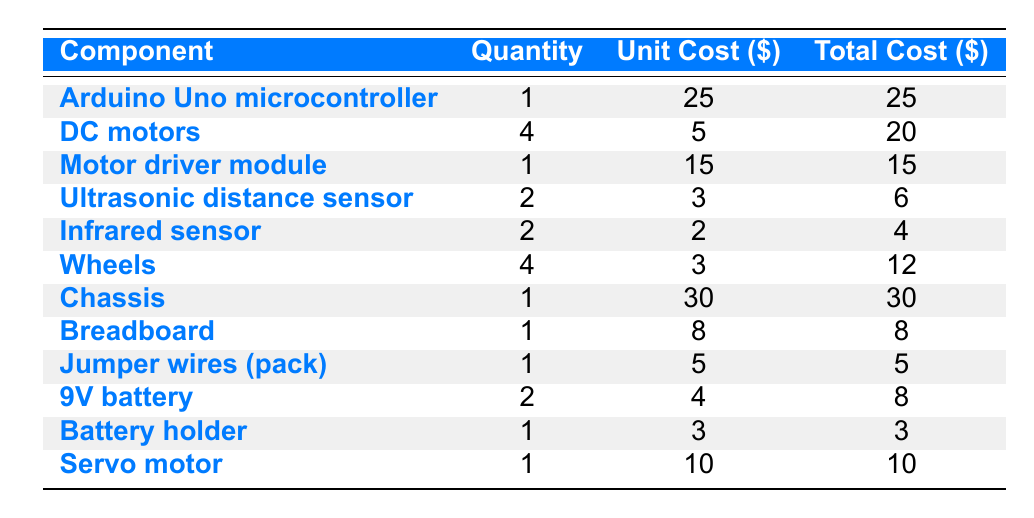What is the total cost for all components? To find the total cost, I need to sum the 'Total Cost ($)' for each component. Adding them up: 25 + 20 + 15 + 6 + 4 + 12 + 30 + 8 + 5 + 8 + 3 + 10 = 142.
Answer: 142 How many DC motors are needed to build the robot? The table explicitly states that 4 DC motors are required to build the robot.
Answer: 4 What is the unit cost of the chassis? The unit cost is provided directly in the table for the chassis, which is listed as 30 dollars.
Answer: 30 Is the total cost of the Arduino Uno microcontroller higher than the total cost of the servo motor? The total cost of the Arduino Uno microcontroller is 25 dollars and for the servo motor, it is 10 dollars. Since 25 is greater than 10, the statement is true.
Answer: Yes What is the average unit cost of the sensors (ultrasonic and infrared)? To find the average unit cost of the sensors, first identify their unit costs: ultrasonic sensor is 3 dollars (2 units) and infrared sensor is 2 dollars (2 units). The total combined unit cost is (3 + 2) = 5. There are a total of 2 types of sensors, so the average is 5/2 = 2.5.
Answer: 2.5 Which component has the highest total cost and what is the amount? By reviewing the 'Total Cost ($)' column, the chassis has the highest total cost at 30 dollars.
Answer: Chassis, 30 How many components have a unit cost lower than 5 dollars? Examining the 'Unit Cost ($)' column, the ultrasonic sensor (3), infrared sensor (2), wheels (3), and battery holder (3) have unit costs lower than 5 dollars. There are 4 components that meet this criterion.
Answer: 4 What is the total cost of all motors (DC and servo)? The total cost of the DC motors is 20 dollars (for 4 motors) and the servo motor costs 10 dollars. Adding these amounts gives 20 + 10 = 30 dollars.
Answer: 30 Is the quantity of wheels equal to the quantity of DC motors? The quantity of wheels is 4, and the quantity of DC motors is also 4. Therefore, they are equal, making the statement true.
Answer: Yes 